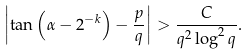Convert formula to latex. <formula><loc_0><loc_0><loc_500><loc_500>\left | \tan \left ( \alpha - 2 ^ { - k } \right ) - \frac { p } { q } \right | > \frac { C } { q ^ { 2 } \log ^ { 2 } q } .</formula> 